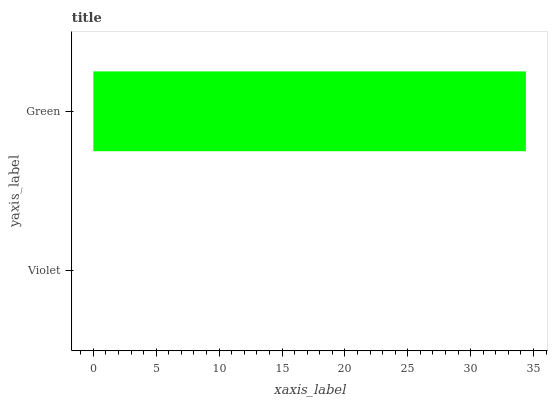Is Violet the minimum?
Answer yes or no. Yes. Is Green the maximum?
Answer yes or no. Yes. Is Green the minimum?
Answer yes or no. No. Is Green greater than Violet?
Answer yes or no. Yes. Is Violet less than Green?
Answer yes or no. Yes. Is Violet greater than Green?
Answer yes or no. No. Is Green less than Violet?
Answer yes or no. No. Is Green the high median?
Answer yes or no. Yes. Is Violet the low median?
Answer yes or no. Yes. Is Violet the high median?
Answer yes or no. No. Is Green the low median?
Answer yes or no. No. 